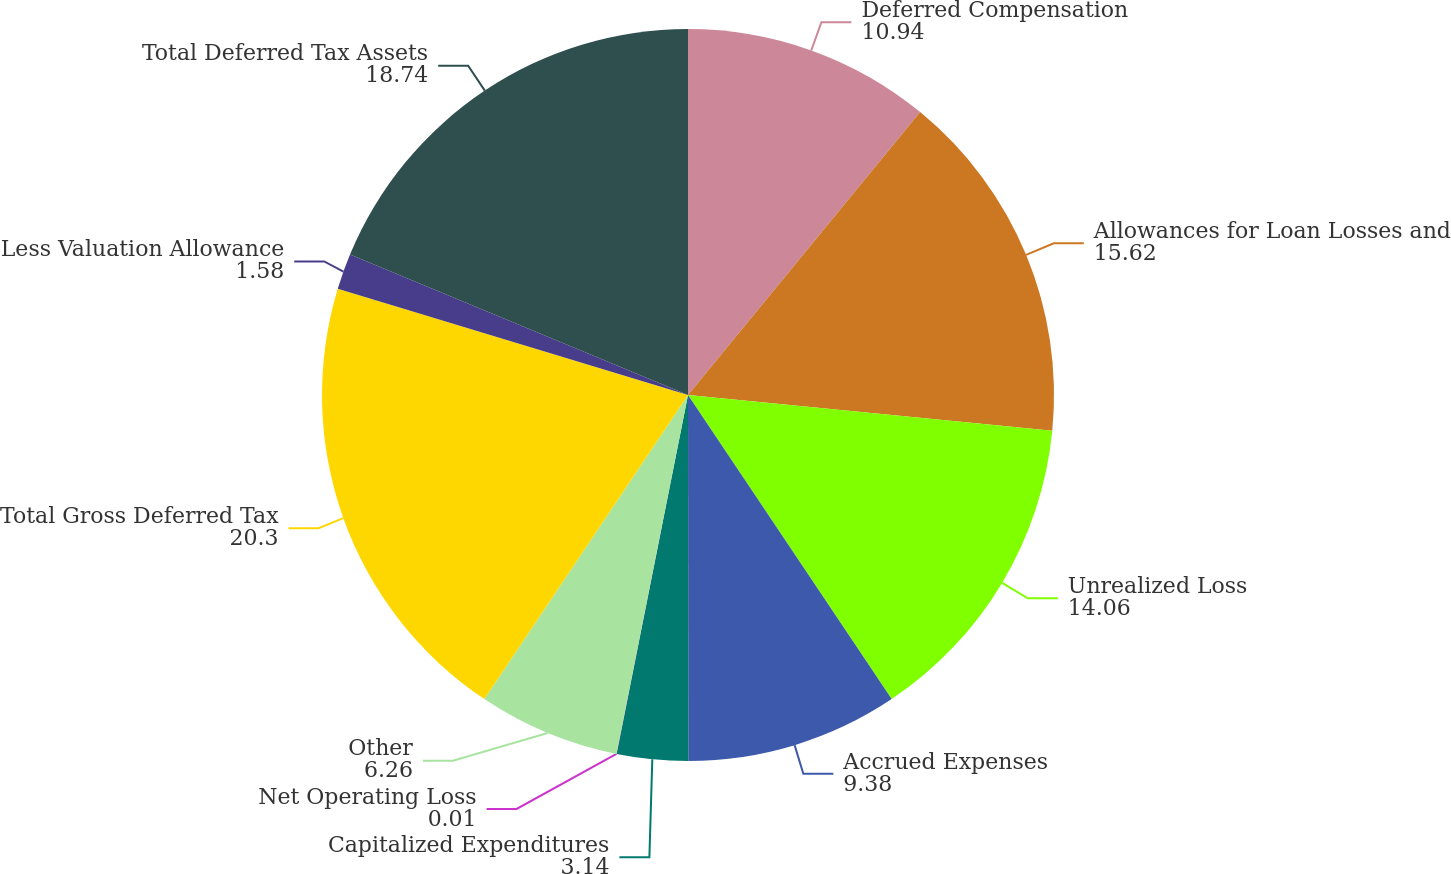Convert chart to OTSL. <chart><loc_0><loc_0><loc_500><loc_500><pie_chart><fcel>Deferred Compensation<fcel>Allowances for Loan Losses and<fcel>Unrealized Loss<fcel>Accrued Expenses<fcel>Capitalized Expenditures<fcel>Net Operating Loss<fcel>Other<fcel>Total Gross Deferred Tax<fcel>Less Valuation Allowance<fcel>Total Deferred Tax Assets<nl><fcel>10.94%<fcel>15.62%<fcel>14.06%<fcel>9.38%<fcel>3.14%<fcel>0.01%<fcel>6.26%<fcel>20.3%<fcel>1.58%<fcel>18.74%<nl></chart> 